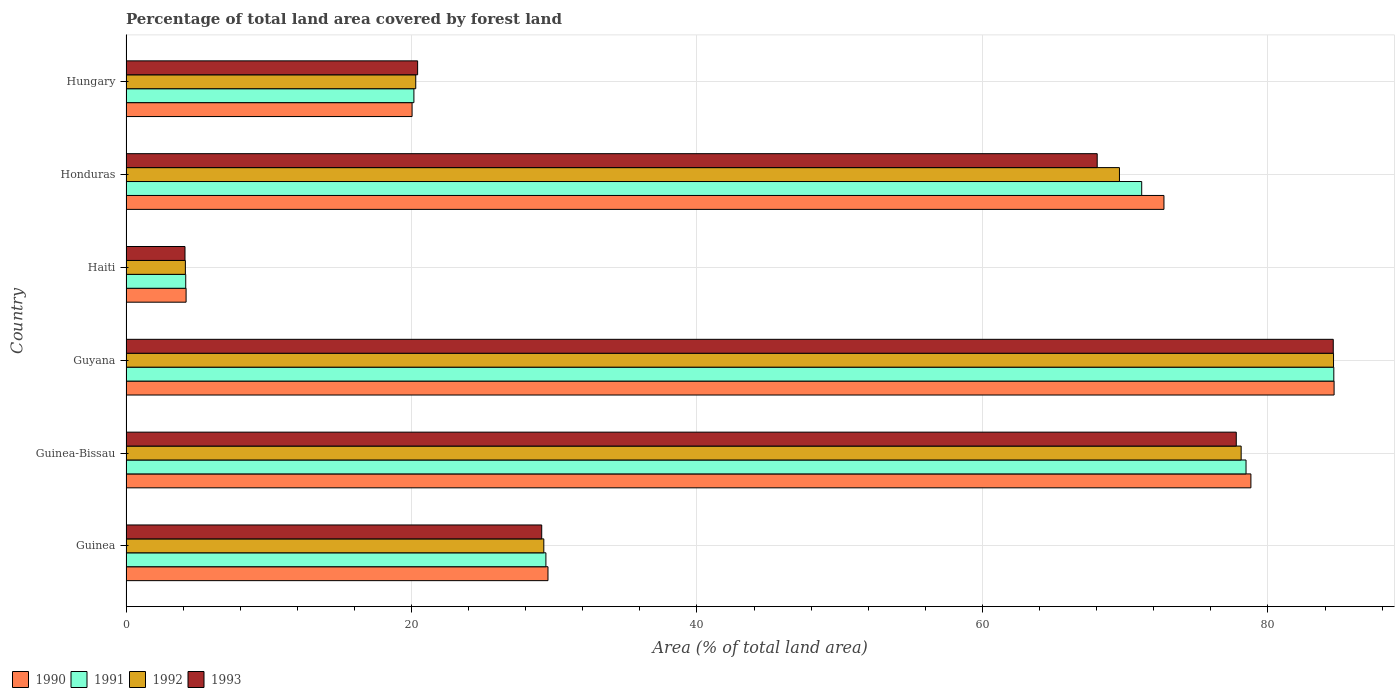How many groups of bars are there?
Make the answer very short. 6. Are the number of bars per tick equal to the number of legend labels?
Give a very brief answer. Yes. How many bars are there on the 4th tick from the bottom?
Ensure brevity in your answer.  4. What is the label of the 6th group of bars from the top?
Your answer should be compact. Guinea. What is the percentage of forest land in 1990 in Guinea?
Your response must be concise. 29.56. Across all countries, what is the maximum percentage of forest land in 1993?
Provide a succinct answer. 84.58. Across all countries, what is the minimum percentage of forest land in 1991?
Keep it short and to the point. 4.18. In which country was the percentage of forest land in 1993 maximum?
Provide a succinct answer. Guyana. In which country was the percentage of forest land in 1990 minimum?
Provide a short and direct response. Haiti. What is the total percentage of forest land in 1990 in the graph?
Your answer should be very brief. 289.96. What is the difference between the percentage of forest land in 1991 in Guinea and that in Guyana?
Offer a very short reply. -55.2. What is the difference between the percentage of forest land in 1993 in Guinea and the percentage of forest land in 1990 in Guyana?
Keep it short and to the point. -55.51. What is the average percentage of forest land in 1992 per country?
Offer a terse response. 47.67. What is the difference between the percentage of forest land in 1991 and percentage of forest land in 1990 in Guinea?
Your answer should be compact. -0.15. What is the ratio of the percentage of forest land in 1991 in Guinea-Bissau to that in Haiti?
Offer a terse response. 18.76. Is the percentage of forest land in 1992 in Guyana less than that in Honduras?
Make the answer very short. No. What is the difference between the highest and the second highest percentage of forest land in 1993?
Give a very brief answer. 6.79. What is the difference between the highest and the lowest percentage of forest land in 1992?
Your response must be concise. 80.44. Is the sum of the percentage of forest land in 1990 in Guyana and Haiti greater than the maximum percentage of forest land in 1991 across all countries?
Give a very brief answer. Yes. What does the 2nd bar from the bottom in Guyana represents?
Your response must be concise. 1991. Are all the bars in the graph horizontal?
Your response must be concise. Yes. How many countries are there in the graph?
Provide a short and direct response. 6. Does the graph contain grids?
Keep it short and to the point. Yes. What is the title of the graph?
Your answer should be compact. Percentage of total land area covered by forest land. What is the label or title of the X-axis?
Provide a succinct answer. Area (% of total land area). What is the label or title of the Y-axis?
Give a very brief answer. Country. What is the Area (% of total land area) in 1990 in Guinea?
Give a very brief answer. 29.56. What is the Area (% of total land area) of 1991 in Guinea?
Keep it short and to the point. 29.42. What is the Area (% of total land area) of 1992 in Guinea?
Keep it short and to the point. 29.27. What is the Area (% of total land area) in 1993 in Guinea?
Offer a very short reply. 29.12. What is the Area (% of total land area) in 1990 in Guinea-Bissau?
Keep it short and to the point. 78.81. What is the Area (% of total land area) in 1991 in Guinea-Bissau?
Make the answer very short. 78.46. What is the Area (% of total land area) in 1992 in Guinea-Bissau?
Offer a very short reply. 78.12. What is the Area (% of total land area) of 1993 in Guinea-Bissau?
Provide a short and direct response. 77.78. What is the Area (% of total land area) in 1990 in Guyana?
Your answer should be compact. 84.63. What is the Area (% of total land area) in 1991 in Guyana?
Offer a very short reply. 84.61. What is the Area (% of total land area) of 1992 in Guyana?
Provide a short and direct response. 84.59. What is the Area (% of total land area) of 1993 in Guyana?
Your answer should be very brief. 84.58. What is the Area (% of total land area) in 1990 in Haiti?
Your answer should be compact. 4.21. What is the Area (% of total land area) in 1991 in Haiti?
Offer a very short reply. 4.18. What is the Area (% of total land area) of 1992 in Haiti?
Provide a succinct answer. 4.16. What is the Area (% of total land area) of 1993 in Haiti?
Make the answer very short. 4.13. What is the Area (% of total land area) of 1990 in Honduras?
Offer a very short reply. 72.71. What is the Area (% of total land area) in 1991 in Honduras?
Your answer should be very brief. 71.16. What is the Area (% of total land area) of 1992 in Honduras?
Make the answer very short. 69.6. What is the Area (% of total land area) in 1993 in Honduras?
Offer a very short reply. 68.04. What is the Area (% of total land area) in 1990 in Hungary?
Keep it short and to the point. 20.04. What is the Area (% of total land area) of 1991 in Hungary?
Give a very brief answer. 20.17. What is the Area (% of total land area) of 1992 in Hungary?
Give a very brief answer. 20.3. What is the Area (% of total land area) in 1993 in Hungary?
Give a very brief answer. 20.43. Across all countries, what is the maximum Area (% of total land area) in 1990?
Offer a terse response. 84.63. Across all countries, what is the maximum Area (% of total land area) of 1991?
Your response must be concise. 84.61. Across all countries, what is the maximum Area (% of total land area) in 1992?
Ensure brevity in your answer.  84.59. Across all countries, what is the maximum Area (% of total land area) of 1993?
Provide a short and direct response. 84.58. Across all countries, what is the minimum Area (% of total land area) in 1990?
Offer a terse response. 4.21. Across all countries, what is the minimum Area (% of total land area) of 1991?
Your response must be concise. 4.18. Across all countries, what is the minimum Area (% of total land area) in 1992?
Your answer should be very brief. 4.16. Across all countries, what is the minimum Area (% of total land area) of 1993?
Ensure brevity in your answer.  4.13. What is the total Area (% of total land area) in 1990 in the graph?
Give a very brief answer. 289.96. What is the total Area (% of total land area) of 1991 in the graph?
Your answer should be compact. 288. What is the total Area (% of total land area) in 1992 in the graph?
Ensure brevity in your answer.  286.04. What is the total Area (% of total land area) of 1993 in the graph?
Your answer should be very brief. 284.08. What is the difference between the Area (% of total land area) of 1990 in Guinea and that in Guinea-Bissau?
Provide a succinct answer. -49.24. What is the difference between the Area (% of total land area) in 1991 in Guinea and that in Guinea-Bissau?
Provide a succinct answer. -49.05. What is the difference between the Area (% of total land area) in 1992 in Guinea and that in Guinea-Bissau?
Offer a very short reply. -48.85. What is the difference between the Area (% of total land area) in 1993 in Guinea and that in Guinea-Bissau?
Ensure brevity in your answer.  -48.66. What is the difference between the Area (% of total land area) of 1990 in Guinea and that in Guyana?
Keep it short and to the point. -55.07. What is the difference between the Area (% of total land area) of 1991 in Guinea and that in Guyana?
Provide a succinct answer. -55.2. What is the difference between the Area (% of total land area) of 1992 in Guinea and that in Guyana?
Provide a short and direct response. -55.33. What is the difference between the Area (% of total land area) of 1993 in Guinea and that in Guyana?
Ensure brevity in your answer.  -55.45. What is the difference between the Area (% of total land area) of 1990 in Guinea and that in Haiti?
Your response must be concise. 25.35. What is the difference between the Area (% of total land area) of 1991 in Guinea and that in Haiti?
Offer a very short reply. 25.23. What is the difference between the Area (% of total land area) in 1992 in Guinea and that in Haiti?
Provide a succinct answer. 25.11. What is the difference between the Area (% of total land area) in 1993 in Guinea and that in Haiti?
Your response must be concise. 24.99. What is the difference between the Area (% of total land area) of 1990 in Guinea and that in Honduras?
Provide a succinct answer. -43.15. What is the difference between the Area (% of total land area) in 1991 in Guinea and that in Honduras?
Offer a very short reply. -41.74. What is the difference between the Area (% of total land area) of 1992 in Guinea and that in Honduras?
Provide a short and direct response. -40.33. What is the difference between the Area (% of total land area) of 1993 in Guinea and that in Honduras?
Offer a terse response. -38.92. What is the difference between the Area (% of total land area) of 1990 in Guinea and that in Hungary?
Ensure brevity in your answer.  9.52. What is the difference between the Area (% of total land area) of 1991 in Guinea and that in Hungary?
Keep it short and to the point. 9.25. What is the difference between the Area (% of total land area) in 1992 in Guinea and that in Hungary?
Provide a short and direct response. 8.97. What is the difference between the Area (% of total land area) in 1993 in Guinea and that in Hungary?
Your response must be concise. 8.69. What is the difference between the Area (% of total land area) of 1990 in Guinea-Bissau and that in Guyana?
Your response must be concise. -5.83. What is the difference between the Area (% of total land area) in 1991 in Guinea-Bissau and that in Guyana?
Your answer should be very brief. -6.15. What is the difference between the Area (% of total land area) of 1992 in Guinea-Bissau and that in Guyana?
Offer a terse response. -6.47. What is the difference between the Area (% of total land area) of 1993 in Guinea-Bissau and that in Guyana?
Your answer should be compact. -6.79. What is the difference between the Area (% of total land area) in 1990 in Guinea-Bissau and that in Haiti?
Your answer should be very brief. 74.6. What is the difference between the Area (% of total land area) in 1991 in Guinea-Bissau and that in Haiti?
Offer a terse response. 74.28. What is the difference between the Area (% of total land area) of 1992 in Guinea-Bissau and that in Haiti?
Offer a terse response. 73.96. What is the difference between the Area (% of total land area) of 1993 in Guinea-Bissau and that in Haiti?
Provide a succinct answer. 73.65. What is the difference between the Area (% of total land area) in 1990 in Guinea-Bissau and that in Honduras?
Offer a very short reply. 6.09. What is the difference between the Area (% of total land area) in 1991 in Guinea-Bissau and that in Honduras?
Keep it short and to the point. 7.31. What is the difference between the Area (% of total land area) in 1992 in Guinea-Bissau and that in Honduras?
Make the answer very short. 8.53. What is the difference between the Area (% of total land area) of 1993 in Guinea-Bissau and that in Honduras?
Your answer should be very brief. 9.74. What is the difference between the Area (% of total land area) of 1990 in Guinea-Bissau and that in Hungary?
Your answer should be compact. 58.77. What is the difference between the Area (% of total land area) of 1991 in Guinea-Bissau and that in Hungary?
Offer a very short reply. 58.29. What is the difference between the Area (% of total land area) of 1992 in Guinea-Bissau and that in Hungary?
Your answer should be compact. 57.82. What is the difference between the Area (% of total land area) in 1993 in Guinea-Bissau and that in Hungary?
Give a very brief answer. 57.35. What is the difference between the Area (% of total land area) of 1990 in Guyana and that in Haiti?
Offer a very short reply. 80.42. What is the difference between the Area (% of total land area) in 1991 in Guyana and that in Haiti?
Keep it short and to the point. 80.43. What is the difference between the Area (% of total land area) of 1992 in Guyana and that in Haiti?
Your answer should be compact. 80.44. What is the difference between the Area (% of total land area) of 1993 in Guyana and that in Haiti?
Provide a short and direct response. 80.44. What is the difference between the Area (% of total land area) of 1990 in Guyana and that in Honduras?
Offer a very short reply. 11.92. What is the difference between the Area (% of total land area) in 1991 in Guyana and that in Honduras?
Keep it short and to the point. 13.46. What is the difference between the Area (% of total land area) of 1992 in Guyana and that in Honduras?
Make the answer very short. 15. What is the difference between the Area (% of total land area) in 1993 in Guyana and that in Honduras?
Make the answer very short. 16.54. What is the difference between the Area (% of total land area) of 1990 in Guyana and that in Hungary?
Provide a succinct answer. 64.59. What is the difference between the Area (% of total land area) of 1991 in Guyana and that in Hungary?
Ensure brevity in your answer.  64.44. What is the difference between the Area (% of total land area) in 1992 in Guyana and that in Hungary?
Give a very brief answer. 64.3. What is the difference between the Area (% of total land area) in 1993 in Guyana and that in Hungary?
Ensure brevity in your answer.  64.15. What is the difference between the Area (% of total land area) in 1990 in Haiti and that in Honduras?
Your answer should be compact. -68.51. What is the difference between the Area (% of total land area) in 1991 in Haiti and that in Honduras?
Give a very brief answer. -66.97. What is the difference between the Area (% of total land area) in 1992 in Haiti and that in Honduras?
Your answer should be compact. -65.44. What is the difference between the Area (% of total land area) of 1993 in Haiti and that in Honduras?
Offer a terse response. -63.91. What is the difference between the Area (% of total land area) in 1990 in Haiti and that in Hungary?
Offer a very short reply. -15.83. What is the difference between the Area (% of total land area) of 1991 in Haiti and that in Hungary?
Ensure brevity in your answer.  -15.99. What is the difference between the Area (% of total land area) in 1992 in Haiti and that in Hungary?
Keep it short and to the point. -16.14. What is the difference between the Area (% of total land area) in 1993 in Haiti and that in Hungary?
Give a very brief answer. -16.3. What is the difference between the Area (% of total land area) of 1990 in Honduras and that in Hungary?
Provide a short and direct response. 52.67. What is the difference between the Area (% of total land area) in 1991 in Honduras and that in Hungary?
Give a very brief answer. 50.99. What is the difference between the Area (% of total land area) of 1992 in Honduras and that in Hungary?
Your answer should be very brief. 49.3. What is the difference between the Area (% of total land area) of 1993 in Honduras and that in Hungary?
Your answer should be very brief. 47.61. What is the difference between the Area (% of total land area) of 1990 in Guinea and the Area (% of total land area) of 1991 in Guinea-Bissau?
Provide a short and direct response. -48.9. What is the difference between the Area (% of total land area) of 1990 in Guinea and the Area (% of total land area) of 1992 in Guinea-Bissau?
Give a very brief answer. -48.56. What is the difference between the Area (% of total land area) in 1990 in Guinea and the Area (% of total land area) in 1993 in Guinea-Bissau?
Ensure brevity in your answer.  -48.22. What is the difference between the Area (% of total land area) in 1991 in Guinea and the Area (% of total land area) in 1992 in Guinea-Bissau?
Give a very brief answer. -48.71. What is the difference between the Area (% of total land area) in 1991 in Guinea and the Area (% of total land area) in 1993 in Guinea-Bissau?
Offer a very short reply. -48.37. What is the difference between the Area (% of total land area) of 1992 in Guinea and the Area (% of total land area) of 1993 in Guinea-Bissau?
Provide a succinct answer. -48.51. What is the difference between the Area (% of total land area) of 1990 in Guinea and the Area (% of total land area) of 1991 in Guyana?
Provide a short and direct response. -55.05. What is the difference between the Area (% of total land area) in 1990 in Guinea and the Area (% of total land area) in 1992 in Guyana?
Your answer should be very brief. -55.03. What is the difference between the Area (% of total land area) in 1990 in Guinea and the Area (% of total land area) in 1993 in Guyana?
Your answer should be very brief. -55.01. What is the difference between the Area (% of total land area) in 1991 in Guinea and the Area (% of total land area) in 1992 in Guyana?
Keep it short and to the point. -55.18. What is the difference between the Area (% of total land area) of 1991 in Guinea and the Area (% of total land area) of 1993 in Guyana?
Make the answer very short. -55.16. What is the difference between the Area (% of total land area) in 1992 in Guinea and the Area (% of total land area) in 1993 in Guyana?
Provide a short and direct response. -55.31. What is the difference between the Area (% of total land area) of 1990 in Guinea and the Area (% of total land area) of 1991 in Haiti?
Offer a terse response. 25.38. What is the difference between the Area (% of total land area) in 1990 in Guinea and the Area (% of total land area) in 1992 in Haiti?
Offer a terse response. 25.4. What is the difference between the Area (% of total land area) in 1990 in Guinea and the Area (% of total land area) in 1993 in Haiti?
Ensure brevity in your answer.  25.43. What is the difference between the Area (% of total land area) in 1991 in Guinea and the Area (% of total land area) in 1992 in Haiti?
Ensure brevity in your answer.  25.26. What is the difference between the Area (% of total land area) of 1991 in Guinea and the Area (% of total land area) of 1993 in Haiti?
Ensure brevity in your answer.  25.28. What is the difference between the Area (% of total land area) in 1992 in Guinea and the Area (% of total land area) in 1993 in Haiti?
Your answer should be very brief. 25.14. What is the difference between the Area (% of total land area) of 1990 in Guinea and the Area (% of total land area) of 1991 in Honduras?
Offer a terse response. -41.59. What is the difference between the Area (% of total land area) in 1990 in Guinea and the Area (% of total land area) in 1992 in Honduras?
Ensure brevity in your answer.  -40.03. What is the difference between the Area (% of total land area) in 1990 in Guinea and the Area (% of total land area) in 1993 in Honduras?
Offer a terse response. -38.48. What is the difference between the Area (% of total land area) in 1991 in Guinea and the Area (% of total land area) in 1992 in Honduras?
Offer a very short reply. -40.18. What is the difference between the Area (% of total land area) of 1991 in Guinea and the Area (% of total land area) of 1993 in Honduras?
Provide a short and direct response. -38.62. What is the difference between the Area (% of total land area) of 1992 in Guinea and the Area (% of total land area) of 1993 in Honduras?
Make the answer very short. -38.77. What is the difference between the Area (% of total land area) in 1990 in Guinea and the Area (% of total land area) in 1991 in Hungary?
Give a very brief answer. 9.39. What is the difference between the Area (% of total land area) of 1990 in Guinea and the Area (% of total land area) of 1992 in Hungary?
Provide a short and direct response. 9.26. What is the difference between the Area (% of total land area) in 1990 in Guinea and the Area (% of total land area) in 1993 in Hungary?
Your answer should be compact. 9.13. What is the difference between the Area (% of total land area) of 1991 in Guinea and the Area (% of total land area) of 1992 in Hungary?
Give a very brief answer. 9.12. What is the difference between the Area (% of total land area) of 1991 in Guinea and the Area (% of total land area) of 1993 in Hungary?
Give a very brief answer. 8.99. What is the difference between the Area (% of total land area) of 1992 in Guinea and the Area (% of total land area) of 1993 in Hungary?
Keep it short and to the point. 8.84. What is the difference between the Area (% of total land area) of 1990 in Guinea-Bissau and the Area (% of total land area) of 1991 in Guyana?
Your answer should be compact. -5.81. What is the difference between the Area (% of total land area) in 1990 in Guinea-Bissau and the Area (% of total land area) in 1992 in Guyana?
Give a very brief answer. -5.79. What is the difference between the Area (% of total land area) in 1990 in Guinea-Bissau and the Area (% of total land area) in 1993 in Guyana?
Provide a succinct answer. -5.77. What is the difference between the Area (% of total land area) of 1991 in Guinea-Bissau and the Area (% of total land area) of 1992 in Guyana?
Make the answer very short. -6.13. What is the difference between the Area (% of total land area) of 1991 in Guinea-Bissau and the Area (% of total land area) of 1993 in Guyana?
Your answer should be very brief. -6.11. What is the difference between the Area (% of total land area) of 1992 in Guinea-Bissau and the Area (% of total land area) of 1993 in Guyana?
Provide a short and direct response. -6.45. What is the difference between the Area (% of total land area) in 1990 in Guinea-Bissau and the Area (% of total land area) in 1991 in Haiti?
Your response must be concise. 74.62. What is the difference between the Area (% of total land area) in 1990 in Guinea-Bissau and the Area (% of total land area) in 1992 in Haiti?
Provide a short and direct response. 74.65. What is the difference between the Area (% of total land area) of 1990 in Guinea-Bissau and the Area (% of total land area) of 1993 in Haiti?
Keep it short and to the point. 74.67. What is the difference between the Area (% of total land area) in 1991 in Guinea-Bissau and the Area (% of total land area) in 1992 in Haiti?
Your answer should be very brief. 74.31. What is the difference between the Area (% of total land area) of 1991 in Guinea-Bissau and the Area (% of total land area) of 1993 in Haiti?
Your answer should be very brief. 74.33. What is the difference between the Area (% of total land area) of 1992 in Guinea-Bissau and the Area (% of total land area) of 1993 in Haiti?
Provide a short and direct response. 73.99. What is the difference between the Area (% of total land area) of 1990 in Guinea-Bissau and the Area (% of total land area) of 1991 in Honduras?
Offer a very short reply. 7.65. What is the difference between the Area (% of total land area) of 1990 in Guinea-Bissau and the Area (% of total land area) of 1992 in Honduras?
Your answer should be very brief. 9.21. What is the difference between the Area (% of total land area) of 1990 in Guinea-Bissau and the Area (% of total land area) of 1993 in Honduras?
Your answer should be compact. 10.77. What is the difference between the Area (% of total land area) of 1991 in Guinea-Bissau and the Area (% of total land area) of 1992 in Honduras?
Offer a terse response. 8.87. What is the difference between the Area (% of total land area) of 1991 in Guinea-Bissau and the Area (% of total land area) of 1993 in Honduras?
Offer a very short reply. 10.43. What is the difference between the Area (% of total land area) of 1992 in Guinea-Bissau and the Area (% of total land area) of 1993 in Honduras?
Your response must be concise. 10.08. What is the difference between the Area (% of total land area) of 1990 in Guinea-Bissau and the Area (% of total land area) of 1991 in Hungary?
Your answer should be very brief. 58.64. What is the difference between the Area (% of total land area) in 1990 in Guinea-Bissau and the Area (% of total land area) in 1992 in Hungary?
Keep it short and to the point. 58.51. What is the difference between the Area (% of total land area) in 1990 in Guinea-Bissau and the Area (% of total land area) in 1993 in Hungary?
Your answer should be very brief. 58.38. What is the difference between the Area (% of total land area) of 1991 in Guinea-Bissau and the Area (% of total land area) of 1992 in Hungary?
Keep it short and to the point. 58.17. What is the difference between the Area (% of total land area) of 1991 in Guinea-Bissau and the Area (% of total land area) of 1993 in Hungary?
Make the answer very short. 58.03. What is the difference between the Area (% of total land area) of 1992 in Guinea-Bissau and the Area (% of total land area) of 1993 in Hungary?
Ensure brevity in your answer.  57.69. What is the difference between the Area (% of total land area) in 1990 in Guyana and the Area (% of total land area) in 1991 in Haiti?
Your answer should be compact. 80.45. What is the difference between the Area (% of total land area) in 1990 in Guyana and the Area (% of total land area) in 1992 in Haiti?
Give a very brief answer. 80.47. What is the difference between the Area (% of total land area) in 1990 in Guyana and the Area (% of total land area) in 1993 in Haiti?
Provide a succinct answer. 80.5. What is the difference between the Area (% of total land area) in 1991 in Guyana and the Area (% of total land area) in 1992 in Haiti?
Provide a succinct answer. 80.46. What is the difference between the Area (% of total land area) of 1991 in Guyana and the Area (% of total land area) of 1993 in Haiti?
Your answer should be very brief. 80.48. What is the difference between the Area (% of total land area) in 1992 in Guyana and the Area (% of total land area) in 1993 in Haiti?
Ensure brevity in your answer.  80.46. What is the difference between the Area (% of total land area) in 1990 in Guyana and the Area (% of total land area) in 1991 in Honduras?
Provide a succinct answer. 13.48. What is the difference between the Area (% of total land area) of 1990 in Guyana and the Area (% of total land area) of 1992 in Honduras?
Provide a succinct answer. 15.04. What is the difference between the Area (% of total land area) of 1990 in Guyana and the Area (% of total land area) of 1993 in Honduras?
Provide a short and direct response. 16.59. What is the difference between the Area (% of total land area) of 1991 in Guyana and the Area (% of total land area) of 1992 in Honduras?
Ensure brevity in your answer.  15.02. What is the difference between the Area (% of total land area) in 1991 in Guyana and the Area (% of total land area) in 1993 in Honduras?
Provide a succinct answer. 16.58. What is the difference between the Area (% of total land area) of 1992 in Guyana and the Area (% of total land area) of 1993 in Honduras?
Your response must be concise. 16.56. What is the difference between the Area (% of total land area) of 1990 in Guyana and the Area (% of total land area) of 1991 in Hungary?
Provide a short and direct response. 64.46. What is the difference between the Area (% of total land area) of 1990 in Guyana and the Area (% of total land area) of 1992 in Hungary?
Your response must be concise. 64.33. What is the difference between the Area (% of total land area) of 1990 in Guyana and the Area (% of total land area) of 1993 in Hungary?
Your answer should be compact. 64.2. What is the difference between the Area (% of total land area) in 1991 in Guyana and the Area (% of total land area) in 1992 in Hungary?
Provide a short and direct response. 64.32. What is the difference between the Area (% of total land area) of 1991 in Guyana and the Area (% of total land area) of 1993 in Hungary?
Ensure brevity in your answer.  64.18. What is the difference between the Area (% of total land area) in 1992 in Guyana and the Area (% of total land area) in 1993 in Hungary?
Give a very brief answer. 64.16. What is the difference between the Area (% of total land area) of 1990 in Haiti and the Area (% of total land area) of 1991 in Honduras?
Offer a terse response. -66.95. What is the difference between the Area (% of total land area) of 1990 in Haiti and the Area (% of total land area) of 1992 in Honduras?
Offer a very short reply. -65.39. What is the difference between the Area (% of total land area) in 1990 in Haiti and the Area (% of total land area) in 1993 in Honduras?
Your answer should be compact. -63.83. What is the difference between the Area (% of total land area) in 1991 in Haiti and the Area (% of total land area) in 1992 in Honduras?
Provide a succinct answer. -65.41. What is the difference between the Area (% of total land area) of 1991 in Haiti and the Area (% of total land area) of 1993 in Honduras?
Your response must be concise. -63.85. What is the difference between the Area (% of total land area) of 1992 in Haiti and the Area (% of total land area) of 1993 in Honduras?
Your answer should be compact. -63.88. What is the difference between the Area (% of total land area) of 1990 in Haiti and the Area (% of total land area) of 1991 in Hungary?
Offer a terse response. -15.96. What is the difference between the Area (% of total land area) in 1990 in Haiti and the Area (% of total land area) in 1992 in Hungary?
Provide a succinct answer. -16.09. What is the difference between the Area (% of total land area) of 1990 in Haiti and the Area (% of total land area) of 1993 in Hungary?
Provide a succinct answer. -16.22. What is the difference between the Area (% of total land area) of 1991 in Haiti and the Area (% of total land area) of 1992 in Hungary?
Provide a short and direct response. -16.11. What is the difference between the Area (% of total land area) in 1991 in Haiti and the Area (% of total land area) in 1993 in Hungary?
Provide a succinct answer. -16.25. What is the difference between the Area (% of total land area) in 1992 in Haiti and the Area (% of total land area) in 1993 in Hungary?
Provide a short and direct response. -16.27. What is the difference between the Area (% of total land area) of 1990 in Honduras and the Area (% of total land area) of 1991 in Hungary?
Give a very brief answer. 52.55. What is the difference between the Area (% of total land area) in 1990 in Honduras and the Area (% of total land area) in 1992 in Hungary?
Make the answer very short. 52.42. What is the difference between the Area (% of total land area) in 1990 in Honduras and the Area (% of total land area) in 1993 in Hungary?
Give a very brief answer. 52.28. What is the difference between the Area (% of total land area) of 1991 in Honduras and the Area (% of total land area) of 1992 in Hungary?
Offer a very short reply. 50.86. What is the difference between the Area (% of total land area) in 1991 in Honduras and the Area (% of total land area) in 1993 in Hungary?
Your response must be concise. 50.73. What is the difference between the Area (% of total land area) of 1992 in Honduras and the Area (% of total land area) of 1993 in Hungary?
Offer a terse response. 49.17. What is the average Area (% of total land area) in 1990 per country?
Offer a very short reply. 48.33. What is the average Area (% of total land area) in 1991 per country?
Offer a terse response. 48. What is the average Area (% of total land area) of 1992 per country?
Provide a short and direct response. 47.67. What is the average Area (% of total land area) of 1993 per country?
Provide a short and direct response. 47.35. What is the difference between the Area (% of total land area) in 1990 and Area (% of total land area) in 1991 in Guinea?
Your answer should be very brief. 0.15. What is the difference between the Area (% of total land area) in 1990 and Area (% of total land area) in 1992 in Guinea?
Offer a very short reply. 0.29. What is the difference between the Area (% of total land area) of 1990 and Area (% of total land area) of 1993 in Guinea?
Your answer should be compact. 0.44. What is the difference between the Area (% of total land area) in 1991 and Area (% of total land area) in 1992 in Guinea?
Your response must be concise. 0.15. What is the difference between the Area (% of total land area) of 1991 and Area (% of total land area) of 1993 in Guinea?
Offer a terse response. 0.29. What is the difference between the Area (% of total land area) of 1992 and Area (% of total land area) of 1993 in Guinea?
Provide a succinct answer. 0.15. What is the difference between the Area (% of total land area) in 1990 and Area (% of total land area) in 1991 in Guinea-Bissau?
Ensure brevity in your answer.  0.34. What is the difference between the Area (% of total land area) of 1990 and Area (% of total land area) of 1992 in Guinea-Bissau?
Provide a short and direct response. 0.68. What is the difference between the Area (% of total land area) of 1990 and Area (% of total land area) of 1993 in Guinea-Bissau?
Your response must be concise. 1.02. What is the difference between the Area (% of total land area) in 1991 and Area (% of total land area) in 1992 in Guinea-Bissau?
Provide a short and direct response. 0.34. What is the difference between the Area (% of total land area) of 1991 and Area (% of total land area) of 1993 in Guinea-Bissau?
Make the answer very short. 0.68. What is the difference between the Area (% of total land area) in 1992 and Area (% of total land area) in 1993 in Guinea-Bissau?
Your answer should be compact. 0.34. What is the difference between the Area (% of total land area) of 1990 and Area (% of total land area) of 1991 in Guyana?
Your response must be concise. 0.02. What is the difference between the Area (% of total land area) in 1990 and Area (% of total land area) in 1992 in Guyana?
Your response must be concise. 0.04. What is the difference between the Area (% of total land area) in 1990 and Area (% of total land area) in 1993 in Guyana?
Keep it short and to the point. 0.06. What is the difference between the Area (% of total land area) in 1991 and Area (% of total land area) in 1992 in Guyana?
Make the answer very short. 0.02. What is the difference between the Area (% of total land area) in 1991 and Area (% of total land area) in 1993 in Guyana?
Your answer should be compact. 0.04. What is the difference between the Area (% of total land area) of 1992 and Area (% of total land area) of 1993 in Guyana?
Your answer should be very brief. 0.02. What is the difference between the Area (% of total land area) of 1990 and Area (% of total land area) of 1991 in Haiti?
Ensure brevity in your answer.  0.03. What is the difference between the Area (% of total land area) of 1990 and Area (% of total land area) of 1992 in Haiti?
Provide a short and direct response. 0.05. What is the difference between the Area (% of total land area) of 1990 and Area (% of total land area) of 1993 in Haiti?
Make the answer very short. 0.08. What is the difference between the Area (% of total land area) in 1991 and Area (% of total land area) in 1992 in Haiti?
Your answer should be very brief. 0.03. What is the difference between the Area (% of total land area) of 1991 and Area (% of total land area) of 1993 in Haiti?
Your answer should be very brief. 0.05. What is the difference between the Area (% of total land area) of 1992 and Area (% of total land area) of 1993 in Haiti?
Offer a very short reply. 0.03. What is the difference between the Area (% of total land area) in 1990 and Area (% of total land area) in 1991 in Honduras?
Offer a terse response. 1.56. What is the difference between the Area (% of total land area) in 1990 and Area (% of total land area) in 1992 in Honduras?
Offer a terse response. 3.12. What is the difference between the Area (% of total land area) in 1990 and Area (% of total land area) in 1993 in Honduras?
Your answer should be compact. 4.68. What is the difference between the Area (% of total land area) of 1991 and Area (% of total land area) of 1992 in Honduras?
Keep it short and to the point. 1.56. What is the difference between the Area (% of total land area) of 1991 and Area (% of total land area) of 1993 in Honduras?
Offer a very short reply. 3.12. What is the difference between the Area (% of total land area) of 1992 and Area (% of total land area) of 1993 in Honduras?
Provide a short and direct response. 1.56. What is the difference between the Area (% of total land area) in 1990 and Area (% of total land area) in 1991 in Hungary?
Provide a succinct answer. -0.13. What is the difference between the Area (% of total land area) of 1990 and Area (% of total land area) of 1992 in Hungary?
Your answer should be compact. -0.26. What is the difference between the Area (% of total land area) of 1990 and Area (% of total land area) of 1993 in Hungary?
Your response must be concise. -0.39. What is the difference between the Area (% of total land area) in 1991 and Area (% of total land area) in 1992 in Hungary?
Offer a terse response. -0.13. What is the difference between the Area (% of total land area) of 1991 and Area (% of total land area) of 1993 in Hungary?
Ensure brevity in your answer.  -0.26. What is the difference between the Area (% of total land area) of 1992 and Area (% of total land area) of 1993 in Hungary?
Make the answer very short. -0.13. What is the ratio of the Area (% of total land area) of 1990 in Guinea to that in Guinea-Bissau?
Your answer should be very brief. 0.38. What is the ratio of the Area (% of total land area) of 1991 in Guinea to that in Guinea-Bissau?
Your answer should be compact. 0.37. What is the ratio of the Area (% of total land area) in 1992 in Guinea to that in Guinea-Bissau?
Offer a very short reply. 0.37. What is the ratio of the Area (% of total land area) in 1993 in Guinea to that in Guinea-Bissau?
Provide a short and direct response. 0.37. What is the ratio of the Area (% of total land area) of 1990 in Guinea to that in Guyana?
Provide a short and direct response. 0.35. What is the ratio of the Area (% of total land area) of 1991 in Guinea to that in Guyana?
Provide a short and direct response. 0.35. What is the ratio of the Area (% of total land area) in 1992 in Guinea to that in Guyana?
Make the answer very short. 0.35. What is the ratio of the Area (% of total land area) of 1993 in Guinea to that in Guyana?
Offer a terse response. 0.34. What is the ratio of the Area (% of total land area) in 1990 in Guinea to that in Haiti?
Ensure brevity in your answer.  7.02. What is the ratio of the Area (% of total land area) in 1991 in Guinea to that in Haiti?
Your response must be concise. 7.03. What is the ratio of the Area (% of total land area) of 1992 in Guinea to that in Haiti?
Give a very brief answer. 7.04. What is the ratio of the Area (% of total land area) of 1993 in Guinea to that in Haiti?
Your answer should be very brief. 7.05. What is the ratio of the Area (% of total land area) in 1990 in Guinea to that in Honduras?
Give a very brief answer. 0.41. What is the ratio of the Area (% of total land area) in 1991 in Guinea to that in Honduras?
Offer a very short reply. 0.41. What is the ratio of the Area (% of total land area) of 1992 in Guinea to that in Honduras?
Offer a terse response. 0.42. What is the ratio of the Area (% of total land area) in 1993 in Guinea to that in Honduras?
Make the answer very short. 0.43. What is the ratio of the Area (% of total land area) of 1990 in Guinea to that in Hungary?
Offer a terse response. 1.48. What is the ratio of the Area (% of total land area) in 1991 in Guinea to that in Hungary?
Ensure brevity in your answer.  1.46. What is the ratio of the Area (% of total land area) in 1992 in Guinea to that in Hungary?
Your response must be concise. 1.44. What is the ratio of the Area (% of total land area) in 1993 in Guinea to that in Hungary?
Provide a succinct answer. 1.43. What is the ratio of the Area (% of total land area) in 1990 in Guinea-Bissau to that in Guyana?
Offer a terse response. 0.93. What is the ratio of the Area (% of total land area) in 1991 in Guinea-Bissau to that in Guyana?
Your answer should be compact. 0.93. What is the ratio of the Area (% of total land area) of 1992 in Guinea-Bissau to that in Guyana?
Provide a succinct answer. 0.92. What is the ratio of the Area (% of total land area) in 1993 in Guinea-Bissau to that in Guyana?
Provide a short and direct response. 0.92. What is the ratio of the Area (% of total land area) in 1990 in Guinea-Bissau to that in Haiti?
Provide a succinct answer. 18.72. What is the ratio of the Area (% of total land area) in 1991 in Guinea-Bissau to that in Haiti?
Make the answer very short. 18.76. What is the ratio of the Area (% of total land area) of 1992 in Guinea-Bissau to that in Haiti?
Your response must be concise. 18.79. What is the ratio of the Area (% of total land area) in 1993 in Guinea-Bissau to that in Haiti?
Give a very brief answer. 18.82. What is the ratio of the Area (% of total land area) in 1990 in Guinea-Bissau to that in Honduras?
Your answer should be compact. 1.08. What is the ratio of the Area (% of total land area) in 1991 in Guinea-Bissau to that in Honduras?
Your response must be concise. 1.1. What is the ratio of the Area (% of total land area) of 1992 in Guinea-Bissau to that in Honduras?
Your answer should be compact. 1.12. What is the ratio of the Area (% of total land area) in 1993 in Guinea-Bissau to that in Honduras?
Provide a short and direct response. 1.14. What is the ratio of the Area (% of total land area) of 1990 in Guinea-Bissau to that in Hungary?
Provide a succinct answer. 3.93. What is the ratio of the Area (% of total land area) of 1991 in Guinea-Bissau to that in Hungary?
Your response must be concise. 3.89. What is the ratio of the Area (% of total land area) in 1992 in Guinea-Bissau to that in Hungary?
Provide a succinct answer. 3.85. What is the ratio of the Area (% of total land area) of 1993 in Guinea-Bissau to that in Hungary?
Your answer should be very brief. 3.81. What is the ratio of the Area (% of total land area) in 1990 in Guyana to that in Haiti?
Your answer should be compact. 20.11. What is the ratio of the Area (% of total land area) in 1991 in Guyana to that in Haiti?
Keep it short and to the point. 20.23. What is the ratio of the Area (% of total land area) of 1992 in Guyana to that in Haiti?
Keep it short and to the point. 20.34. What is the ratio of the Area (% of total land area) in 1993 in Guyana to that in Haiti?
Give a very brief answer. 20.46. What is the ratio of the Area (% of total land area) of 1990 in Guyana to that in Honduras?
Give a very brief answer. 1.16. What is the ratio of the Area (% of total land area) of 1991 in Guyana to that in Honduras?
Provide a succinct answer. 1.19. What is the ratio of the Area (% of total land area) of 1992 in Guyana to that in Honduras?
Provide a succinct answer. 1.22. What is the ratio of the Area (% of total land area) in 1993 in Guyana to that in Honduras?
Ensure brevity in your answer.  1.24. What is the ratio of the Area (% of total land area) of 1990 in Guyana to that in Hungary?
Your response must be concise. 4.22. What is the ratio of the Area (% of total land area) of 1991 in Guyana to that in Hungary?
Give a very brief answer. 4.2. What is the ratio of the Area (% of total land area) in 1992 in Guyana to that in Hungary?
Your answer should be compact. 4.17. What is the ratio of the Area (% of total land area) of 1993 in Guyana to that in Hungary?
Your response must be concise. 4.14. What is the ratio of the Area (% of total land area) in 1990 in Haiti to that in Honduras?
Offer a very short reply. 0.06. What is the ratio of the Area (% of total land area) of 1991 in Haiti to that in Honduras?
Your response must be concise. 0.06. What is the ratio of the Area (% of total land area) of 1992 in Haiti to that in Honduras?
Give a very brief answer. 0.06. What is the ratio of the Area (% of total land area) of 1993 in Haiti to that in Honduras?
Provide a short and direct response. 0.06. What is the ratio of the Area (% of total land area) in 1990 in Haiti to that in Hungary?
Your answer should be very brief. 0.21. What is the ratio of the Area (% of total land area) in 1991 in Haiti to that in Hungary?
Give a very brief answer. 0.21. What is the ratio of the Area (% of total land area) of 1992 in Haiti to that in Hungary?
Offer a very short reply. 0.2. What is the ratio of the Area (% of total land area) in 1993 in Haiti to that in Hungary?
Make the answer very short. 0.2. What is the ratio of the Area (% of total land area) of 1990 in Honduras to that in Hungary?
Provide a succinct answer. 3.63. What is the ratio of the Area (% of total land area) in 1991 in Honduras to that in Hungary?
Give a very brief answer. 3.53. What is the ratio of the Area (% of total land area) of 1992 in Honduras to that in Hungary?
Keep it short and to the point. 3.43. What is the ratio of the Area (% of total land area) of 1993 in Honduras to that in Hungary?
Keep it short and to the point. 3.33. What is the difference between the highest and the second highest Area (% of total land area) of 1990?
Your answer should be very brief. 5.83. What is the difference between the highest and the second highest Area (% of total land area) of 1991?
Offer a terse response. 6.15. What is the difference between the highest and the second highest Area (% of total land area) of 1992?
Your answer should be very brief. 6.47. What is the difference between the highest and the second highest Area (% of total land area) of 1993?
Provide a succinct answer. 6.79. What is the difference between the highest and the lowest Area (% of total land area) in 1990?
Keep it short and to the point. 80.42. What is the difference between the highest and the lowest Area (% of total land area) in 1991?
Keep it short and to the point. 80.43. What is the difference between the highest and the lowest Area (% of total land area) in 1992?
Provide a short and direct response. 80.44. What is the difference between the highest and the lowest Area (% of total land area) of 1993?
Provide a short and direct response. 80.44. 